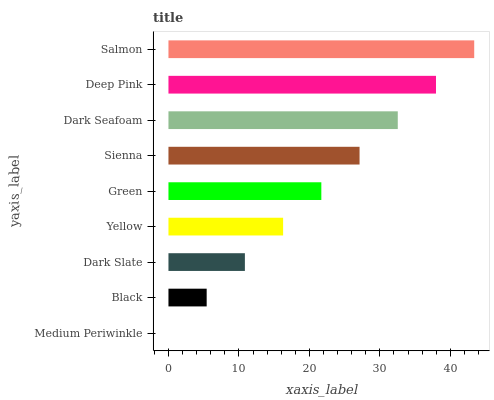Is Medium Periwinkle the minimum?
Answer yes or no. Yes. Is Salmon the maximum?
Answer yes or no. Yes. Is Black the minimum?
Answer yes or no. No. Is Black the maximum?
Answer yes or no. No. Is Black greater than Medium Periwinkle?
Answer yes or no. Yes. Is Medium Periwinkle less than Black?
Answer yes or no. Yes. Is Medium Periwinkle greater than Black?
Answer yes or no. No. Is Black less than Medium Periwinkle?
Answer yes or no. No. Is Green the high median?
Answer yes or no. Yes. Is Green the low median?
Answer yes or no. Yes. Is Black the high median?
Answer yes or no. No. Is Yellow the low median?
Answer yes or no. No. 